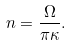<formula> <loc_0><loc_0><loc_500><loc_500>n = \frac { \Omega } { \pi \kappa } .</formula> 